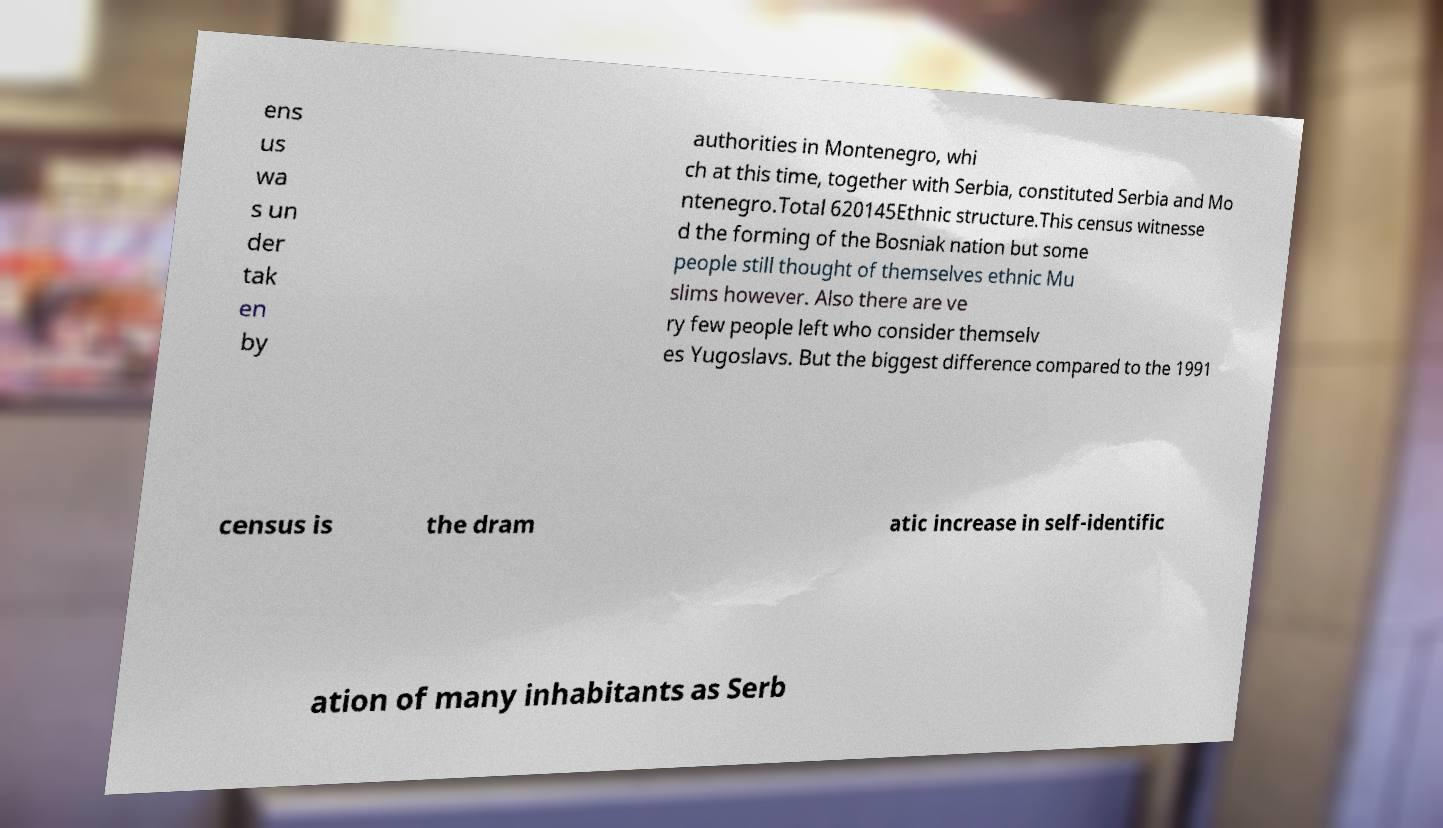Could you extract and type out the text from this image? ens us wa s un der tak en by authorities in Montenegro, whi ch at this time, together with Serbia, constituted Serbia and Mo ntenegro.Total 620145Ethnic structure.This census witnesse d the forming of the Bosniak nation but some people still thought of themselves ethnic Mu slims however. Also there are ve ry few people left who consider themselv es Yugoslavs. But the biggest difference compared to the 1991 census is the dram atic increase in self-identific ation of many inhabitants as Serb 